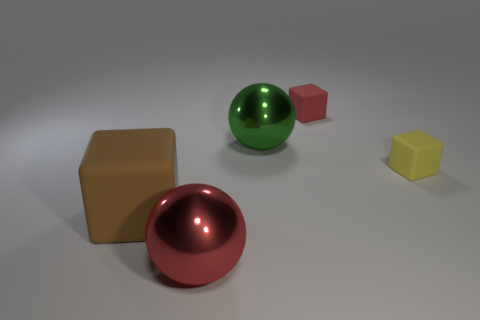Add 1 tiny yellow rubber objects. How many objects exist? 6 Subtract all balls. How many objects are left? 3 Subtract all balls. Subtract all big brown rubber things. How many objects are left? 2 Add 3 tiny things. How many tiny things are left? 5 Add 1 gray metal spheres. How many gray metal spheres exist? 1 Subtract 1 green balls. How many objects are left? 4 